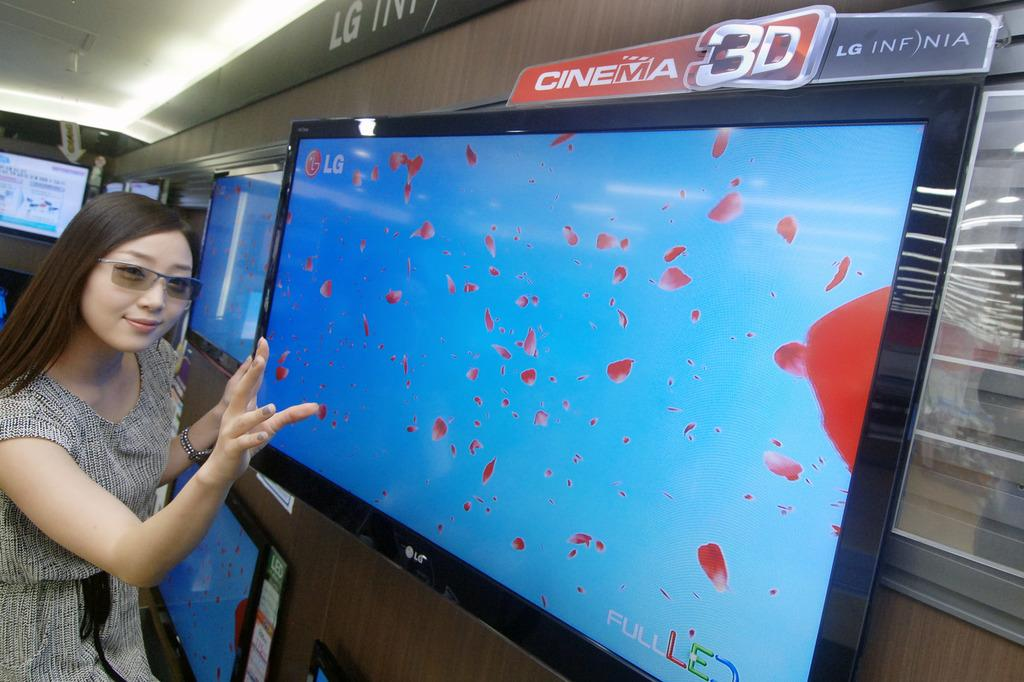Where is the image taken? The image is inside an LG showroom. What can be seen on display in the showroom? There are multiple televisions on display. Is there anyone in the image? Yes, a woman is standing in front of one of the TVs. What is the woman doing in the image? The woman is posing for a photo. What type of plants can be seen growing inside the LG showroom? There is no mention of plants in the image or the provided facts, so we cannot determine if there are any plants inside the LG showroom. 